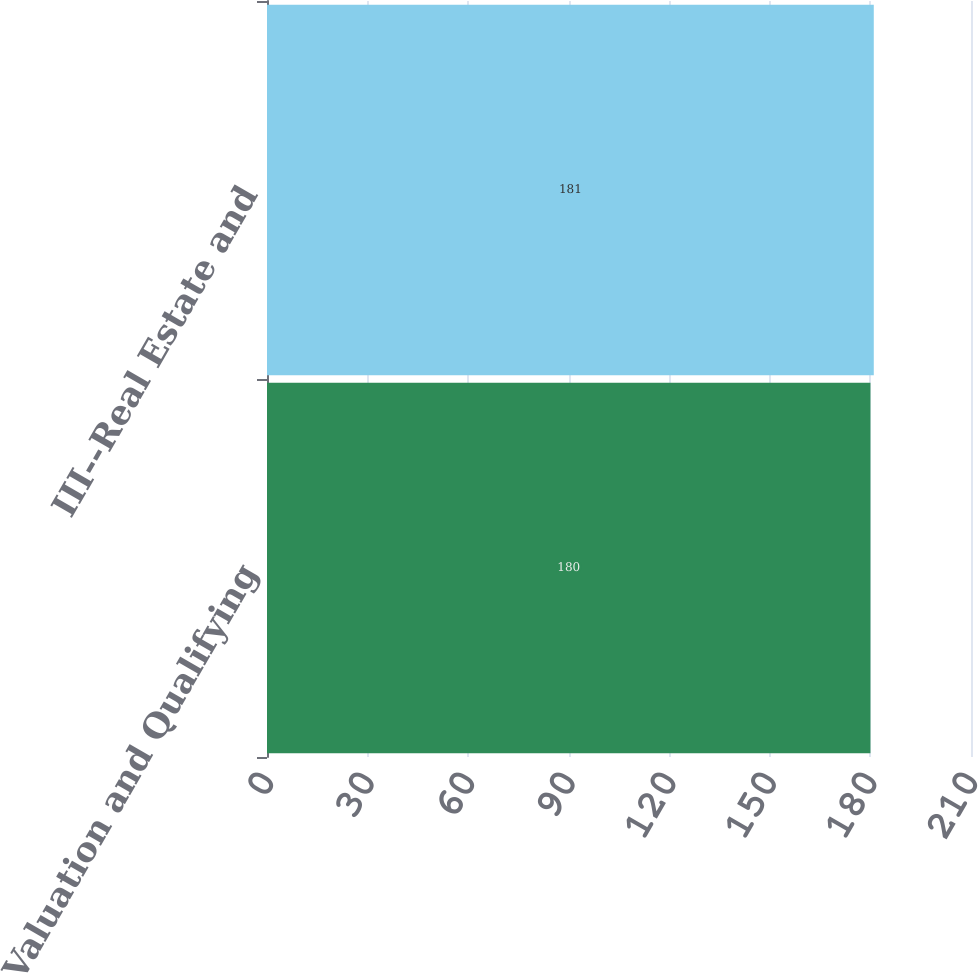Convert chart to OTSL. <chart><loc_0><loc_0><loc_500><loc_500><bar_chart><fcel>II--Valuation and Qualifying<fcel>III--Real Estate and<nl><fcel>180<fcel>181<nl></chart> 